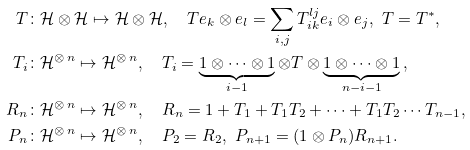Convert formula to latex. <formula><loc_0><loc_0><loc_500><loc_500>T \colon & \mathcal { H } \otimes \mathcal { H } \mapsto \mathcal { H } \otimes \mathcal { H } , \quad T e _ { k } \otimes e _ { l } = \sum _ { i , j } T _ { i k } ^ { l j } e _ { i } \otimes e _ { j } , \ T = T ^ { * } , \\ T _ { i } \colon & \mathcal { H } ^ { \otimes \, n } \mapsto \mathcal { H } ^ { \otimes \, n } , \quad T _ { i } = \underbrace { 1 \otimes \cdots \otimes 1 } _ { i - 1 } \otimes T \otimes \underbrace { 1 \otimes \cdots \otimes 1 } _ { n - i - 1 } \, , \\ R _ { n } \colon & \mathcal { H } ^ { \otimes \, n } \mapsto \mathcal { H } ^ { \otimes \, n } , \quad R _ { n } = 1 + T _ { 1 } + T _ { 1 } T _ { 2 } + \cdots + T _ { 1 } T _ { 2 } \cdots T _ { n - 1 } , \\ P _ { n } \colon & \mathcal { H } ^ { \otimes \, n } \mapsto \mathcal { H } ^ { \otimes \, n } , \quad P _ { 2 } = R _ { 2 } , \ P _ { n + 1 } = ( 1 \otimes P _ { n } ) R _ { n + 1 } .</formula> 